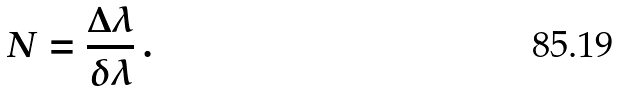<formula> <loc_0><loc_0><loc_500><loc_500>N = \frac { \Delta \lambda } { \delta \lambda } \, .</formula> 